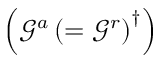<formula> <loc_0><loc_0><loc_500><loc_500>\left ( \mathcal { G } ^ { a } \left ( = \mathcal { G } ^ { r } \right ) ^ { \dagger } \right )</formula> 